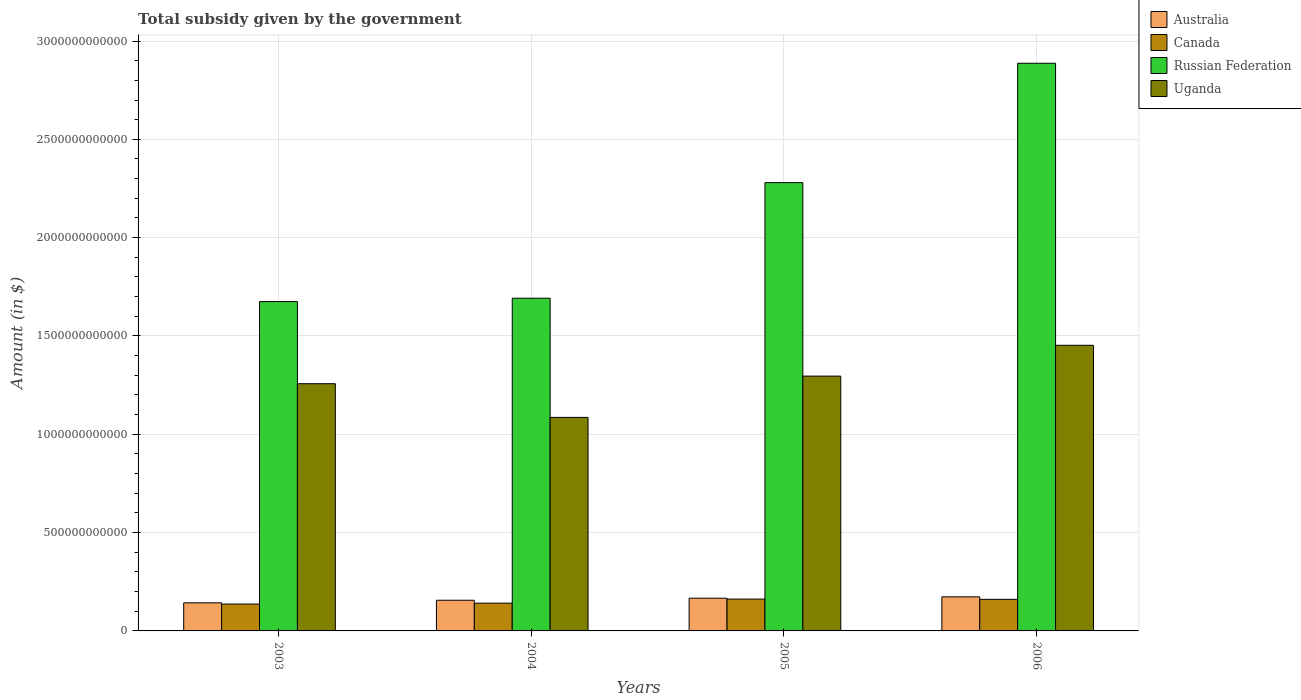How many different coloured bars are there?
Your answer should be very brief. 4. How many groups of bars are there?
Your answer should be very brief. 4. What is the total revenue collected by the government in Canada in 2004?
Your answer should be very brief. 1.41e+11. Across all years, what is the maximum total revenue collected by the government in Canada?
Make the answer very short. 1.62e+11. Across all years, what is the minimum total revenue collected by the government in Australia?
Provide a succinct answer. 1.43e+11. In which year was the total revenue collected by the government in Russian Federation maximum?
Provide a succinct answer. 2006. In which year was the total revenue collected by the government in Russian Federation minimum?
Give a very brief answer. 2003. What is the total total revenue collected by the government in Canada in the graph?
Make the answer very short. 6.00e+11. What is the difference between the total revenue collected by the government in Uganda in 2003 and that in 2004?
Give a very brief answer. 1.71e+11. What is the difference between the total revenue collected by the government in Russian Federation in 2005 and the total revenue collected by the government in Uganda in 2003?
Make the answer very short. 1.02e+12. What is the average total revenue collected by the government in Uganda per year?
Make the answer very short. 1.27e+12. In the year 2005, what is the difference between the total revenue collected by the government in Australia and total revenue collected by the government in Uganda?
Your answer should be very brief. -1.13e+12. What is the ratio of the total revenue collected by the government in Russian Federation in 2005 to that in 2006?
Your answer should be compact. 0.79. What is the difference between the highest and the second highest total revenue collected by the government in Canada?
Offer a very short reply. 1.41e+09. What is the difference between the highest and the lowest total revenue collected by the government in Canada?
Your answer should be compact. 2.53e+1. In how many years, is the total revenue collected by the government in Australia greater than the average total revenue collected by the government in Australia taken over all years?
Offer a terse response. 2. Is the sum of the total revenue collected by the government in Australia in 2005 and 2006 greater than the maximum total revenue collected by the government in Canada across all years?
Provide a short and direct response. Yes. What does the 4th bar from the right in 2004 represents?
Your answer should be compact. Australia. How many years are there in the graph?
Your answer should be compact. 4. What is the difference between two consecutive major ticks on the Y-axis?
Ensure brevity in your answer.  5.00e+11. Does the graph contain any zero values?
Offer a very short reply. No. Does the graph contain grids?
Offer a very short reply. Yes. Where does the legend appear in the graph?
Provide a succinct answer. Top right. How many legend labels are there?
Your answer should be compact. 4. What is the title of the graph?
Ensure brevity in your answer.  Total subsidy given by the government. Does "Fragile and conflict affected situations" appear as one of the legend labels in the graph?
Provide a succinct answer. No. What is the label or title of the X-axis?
Your response must be concise. Years. What is the label or title of the Y-axis?
Make the answer very short. Amount (in $). What is the Amount (in $) of Australia in 2003?
Provide a short and direct response. 1.43e+11. What is the Amount (in $) of Canada in 2003?
Make the answer very short. 1.37e+11. What is the Amount (in $) of Russian Federation in 2003?
Your answer should be very brief. 1.67e+12. What is the Amount (in $) of Uganda in 2003?
Keep it short and to the point. 1.26e+12. What is the Amount (in $) in Australia in 2004?
Your answer should be compact. 1.56e+11. What is the Amount (in $) in Canada in 2004?
Your answer should be compact. 1.41e+11. What is the Amount (in $) in Russian Federation in 2004?
Provide a succinct answer. 1.69e+12. What is the Amount (in $) of Uganda in 2004?
Your answer should be very brief. 1.09e+12. What is the Amount (in $) in Australia in 2005?
Offer a very short reply. 1.66e+11. What is the Amount (in $) of Canada in 2005?
Keep it short and to the point. 1.62e+11. What is the Amount (in $) of Russian Federation in 2005?
Provide a succinct answer. 2.28e+12. What is the Amount (in $) in Uganda in 2005?
Offer a terse response. 1.30e+12. What is the Amount (in $) in Australia in 2006?
Make the answer very short. 1.73e+11. What is the Amount (in $) in Canada in 2006?
Offer a very short reply. 1.61e+11. What is the Amount (in $) in Russian Federation in 2006?
Offer a very short reply. 2.89e+12. What is the Amount (in $) in Uganda in 2006?
Offer a very short reply. 1.45e+12. Across all years, what is the maximum Amount (in $) in Australia?
Make the answer very short. 1.73e+11. Across all years, what is the maximum Amount (in $) of Canada?
Your response must be concise. 1.62e+11. Across all years, what is the maximum Amount (in $) in Russian Federation?
Offer a very short reply. 2.89e+12. Across all years, what is the maximum Amount (in $) of Uganda?
Offer a very short reply. 1.45e+12. Across all years, what is the minimum Amount (in $) of Australia?
Provide a short and direct response. 1.43e+11. Across all years, what is the minimum Amount (in $) in Canada?
Your response must be concise. 1.37e+11. Across all years, what is the minimum Amount (in $) of Russian Federation?
Provide a succinct answer. 1.67e+12. Across all years, what is the minimum Amount (in $) in Uganda?
Provide a short and direct response. 1.09e+12. What is the total Amount (in $) in Australia in the graph?
Your answer should be compact. 6.39e+11. What is the total Amount (in $) in Canada in the graph?
Your answer should be very brief. 6.00e+11. What is the total Amount (in $) in Russian Federation in the graph?
Offer a terse response. 8.53e+12. What is the total Amount (in $) of Uganda in the graph?
Give a very brief answer. 5.09e+12. What is the difference between the Amount (in $) in Australia in 2003 and that in 2004?
Your response must be concise. -1.31e+1. What is the difference between the Amount (in $) in Canada in 2003 and that in 2004?
Keep it short and to the point. -4.56e+09. What is the difference between the Amount (in $) of Russian Federation in 2003 and that in 2004?
Ensure brevity in your answer.  -1.70e+1. What is the difference between the Amount (in $) in Uganda in 2003 and that in 2004?
Provide a short and direct response. 1.71e+11. What is the difference between the Amount (in $) of Australia in 2003 and that in 2005?
Your answer should be very brief. -2.36e+1. What is the difference between the Amount (in $) of Canada in 2003 and that in 2005?
Offer a terse response. -2.53e+1. What is the difference between the Amount (in $) in Russian Federation in 2003 and that in 2005?
Ensure brevity in your answer.  -6.05e+11. What is the difference between the Amount (in $) of Uganda in 2003 and that in 2005?
Your answer should be very brief. -3.86e+1. What is the difference between the Amount (in $) in Australia in 2003 and that in 2006?
Make the answer very short. -3.04e+1. What is the difference between the Amount (in $) in Canada in 2003 and that in 2006?
Offer a very short reply. -2.39e+1. What is the difference between the Amount (in $) of Russian Federation in 2003 and that in 2006?
Make the answer very short. -1.21e+12. What is the difference between the Amount (in $) in Uganda in 2003 and that in 2006?
Provide a succinct answer. -1.95e+11. What is the difference between the Amount (in $) of Australia in 2004 and that in 2005?
Make the answer very short. -1.05e+1. What is the difference between the Amount (in $) of Canada in 2004 and that in 2005?
Offer a terse response. -2.08e+1. What is the difference between the Amount (in $) of Russian Federation in 2004 and that in 2005?
Your answer should be very brief. -5.88e+11. What is the difference between the Amount (in $) of Uganda in 2004 and that in 2005?
Make the answer very short. -2.10e+11. What is the difference between the Amount (in $) in Australia in 2004 and that in 2006?
Give a very brief answer. -1.73e+1. What is the difference between the Amount (in $) of Canada in 2004 and that in 2006?
Keep it short and to the point. -1.94e+1. What is the difference between the Amount (in $) of Russian Federation in 2004 and that in 2006?
Provide a succinct answer. -1.19e+12. What is the difference between the Amount (in $) of Uganda in 2004 and that in 2006?
Your response must be concise. -3.67e+11. What is the difference between the Amount (in $) in Australia in 2005 and that in 2006?
Provide a succinct answer. -6.85e+09. What is the difference between the Amount (in $) in Canada in 2005 and that in 2006?
Your response must be concise. 1.41e+09. What is the difference between the Amount (in $) of Russian Federation in 2005 and that in 2006?
Ensure brevity in your answer.  -6.07e+11. What is the difference between the Amount (in $) of Uganda in 2005 and that in 2006?
Your answer should be compact. -1.57e+11. What is the difference between the Amount (in $) of Australia in 2003 and the Amount (in $) of Canada in 2004?
Your answer should be compact. 1.65e+09. What is the difference between the Amount (in $) in Australia in 2003 and the Amount (in $) in Russian Federation in 2004?
Provide a short and direct response. -1.55e+12. What is the difference between the Amount (in $) in Australia in 2003 and the Amount (in $) in Uganda in 2004?
Your answer should be very brief. -9.43e+11. What is the difference between the Amount (in $) of Canada in 2003 and the Amount (in $) of Russian Federation in 2004?
Provide a succinct answer. -1.56e+12. What is the difference between the Amount (in $) of Canada in 2003 and the Amount (in $) of Uganda in 2004?
Your answer should be compact. -9.49e+11. What is the difference between the Amount (in $) in Russian Federation in 2003 and the Amount (in $) in Uganda in 2004?
Your response must be concise. 5.89e+11. What is the difference between the Amount (in $) of Australia in 2003 and the Amount (in $) of Canada in 2005?
Your response must be concise. -1.91e+1. What is the difference between the Amount (in $) in Australia in 2003 and the Amount (in $) in Russian Federation in 2005?
Offer a terse response. -2.14e+12. What is the difference between the Amount (in $) of Australia in 2003 and the Amount (in $) of Uganda in 2005?
Your answer should be compact. -1.15e+12. What is the difference between the Amount (in $) of Canada in 2003 and the Amount (in $) of Russian Federation in 2005?
Offer a very short reply. -2.14e+12. What is the difference between the Amount (in $) in Canada in 2003 and the Amount (in $) in Uganda in 2005?
Provide a short and direct response. -1.16e+12. What is the difference between the Amount (in $) in Russian Federation in 2003 and the Amount (in $) in Uganda in 2005?
Offer a very short reply. 3.79e+11. What is the difference between the Amount (in $) in Australia in 2003 and the Amount (in $) in Canada in 2006?
Provide a succinct answer. -1.77e+1. What is the difference between the Amount (in $) of Australia in 2003 and the Amount (in $) of Russian Federation in 2006?
Your answer should be very brief. -2.74e+12. What is the difference between the Amount (in $) in Australia in 2003 and the Amount (in $) in Uganda in 2006?
Give a very brief answer. -1.31e+12. What is the difference between the Amount (in $) of Canada in 2003 and the Amount (in $) of Russian Federation in 2006?
Give a very brief answer. -2.75e+12. What is the difference between the Amount (in $) in Canada in 2003 and the Amount (in $) in Uganda in 2006?
Your answer should be very brief. -1.32e+12. What is the difference between the Amount (in $) of Russian Federation in 2003 and the Amount (in $) of Uganda in 2006?
Offer a very short reply. 2.22e+11. What is the difference between the Amount (in $) in Australia in 2004 and the Amount (in $) in Canada in 2005?
Your answer should be very brief. -6.00e+09. What is the difference between the Amount (in $) in Australia in 2004 and the Amount (in $) in Russian Federation in 2005?
Keep it short and to the point. -2.12e+12. What is the difference between the Amount (in $) of Australia in 2004 and the Amount (in $) of Uganda in 2005?
Provide a short and direct response. -1.14e+12. What is the difference between the Amount (in $) in Canada in 2004 and the Amount (in $) in Russian Federation in 2005?
Your answer should be compact. -2.14e+12. What is the difference between the Amount (in $) in Canada in 2004 and the Amount (in $) in Uganda in 2005?
Provide a succinct answer. -1.15e+12. What is the difference between the Amount (in $) in Russian Federation in 2004 and the Amount (in $) in Uganda in 2005?
Offer a terse response. 3.96e+11. What is the difference between the Amount (in $) in Australia in 2004 and the Amount (in $) in Canada in 2006?
Provide a succinct answer. -4.59e+09. What is the difference between the Amount (in $) of Australia in 2004 and the Amount (in $) of Russian Federation in 2006?
Your response must be concise. -2.73e+12. What is the difference between the Amount (in $) in Australia in 2004 and the Amount (in $) in Uganda in 2006?
Your response must be concise. -1.30e+12. What is the difference between the Amount (in $) of Canada in 2004 and the Amount (in $) of Russian Federation in 2006?
Give a very brief answer. -2.75e+12. What is the difference between the Amount (in $) of Canada in 2004 and the Amount (in $) of Uganda in 2006?
Offer a terse response. -1.31e+12. What is the difference between the Amount (in $) of Russian Federation in 2004 and the Amount (in $) of Uganda in 2006?
Ensure brevity in your answer.  2.39e+11. What is the difference between the Amount (in $) of Australia in 2005 and the Amount (in $) of Canada in 2006?
Offer a terse response. 5.89e+09. What is the difference between the Amount (in $) in Australia in 2005 and the Amount (in $) in Russian Federation in 2006?
Your response must be concise. -2.72e+12. What is the difference between the Amount (in $) of Australia in 2005 and the Amount (in $) of Uganda in 2006?
Your response must be concise. -1.29e+12. What is the difference between the Amount (in $) in Canada in 2005 and the Amount (in $) in Russian Federation in 2006?
Your response must be concise. -2.72e+12. What is the difference between the Amount (in $) of Canada in 2005 and the Amount (in $) of Uganda in 2006?
Ensure brevity in your answer.  -1.29e+12. What is the difference between the Amount (in $) in Russian Federation in 2005 and the Amount (in $) in Uganda in 2006?
Offer a very short reply. 8.27e+11. What is the average Amount (in $) in Australia per year?
Give a very brief answer. 1.60e+11. What is the average Amount (in $) in Canada per year?
Your answer should be very brief. 1.50e+11. What is the average Amount (in $) in Russian Federation per year?
Offer a terse response. 2.13e+12. What is the average Amount (in $) in Uganda per year?
Ensure brevity in your answer.  1.27e+12. In the year 2003, what is the difference between the Amount (in $) in Australia and Amount (in $) in Canada?
Make the answer very short. 6.21e+09. In the year 2003, what is the difference between the Amount (in $) in Australia and Amount (in $) in Russian Federation?
Ensure brevity in your answer.  -1.53e+12. In the year 2003, what is the difference between the Amount (in $) in Australia and Amount (in $) in Uganda?
Offer a very short reply. -1.11e+12. In the year 2003, what is the difference between the Amount (in $) of Canada and Amount (in $) of Russian Federation?
Ensure brevity in your answer.  -1.54e+12. In the year 2003, what is the difference between the Amount (in $) of Canada and Amount (in $) of Uganda?
Your answer should be very brief. -1.12e+12. In the year 2003, what is the difference between the Amount (in $) of Russian Federation and Amount (in $) of Uganda?
Your response must be concise. 4.18e+11. In the year 2004, what is the difference between the Amount (in $) in Australia and Amount (in $) in Canada?
Keep it short and to the point. 1.48e+1. In the year 2004, what is the difference between the Amount (in $) in Australia and Amount (in $) in Russian Federation?
Provide a short and direct response. -1.54e+12. In the year 2004, what is the difference between the Amount (in $) in Australia and Amount (in $) in Uganda?
Offer a terse response. -9.30e+11. In the year 2004, what is the difference between the Amount (in $) in Canada and Amount (in $) in Russian Federation?
Your answer should be very brief. -1.55e+12. In the year 2004, what is the difference between the Amount (in $) of Canada and Amount (in $) of Uganda?
Provide a succinct answer. -9.45e+11. In the year 2004, what is the difference between the Amount (in $) in Russian Federation and Amount (in $) in Uganda?
Provide a succinct answer. 6.06e+11. In the year 2005, what is the difference between the Amount (in $) of Australia and Amount (in $) of Canada?
Give a very brief answer. 4.48e+09. In the year 2005, what is the difference between the Amount (in $) of Australia and Amount (in $) of Russian Federation?
Your response must be concise. -2.11e+12. In the year 2005, what is the difference between the Amount (in $) of Australia and Amount (in $) of Uganda?
Offer a terse response. -1.13e+12. In the year 2005, what is the difference between the Amount (in $) in Canada and Amount (in $) in Russian Federation?
Ensure brevity in your answer.  -2.12e+12. In the year 2005, what is the difference between the Amount (in $) in Canada and Amount (in $) in Uganda?
Ensure brevity in your answer.  -1.13e+12. In the year 2005, what is the difference between the Amount (in $) of Russian Federation and Amount (in $) of Uganda?
Provide a succinct answer. 9.84e+11. In the year 2006, what is the difference between the Amount (in $) in Australia and Amount (in $) in Canada?
Your response must be concise. 1.27e+1. In the year 2006, what is the difference between the Amount (in $) in Australia and Amount (in $) in Russian Federation?
Give a very brief answer. -2.71e+12. In the year 2006, what is the difference between the Amount (in $) of Australia and Amount (in $) of Uganda?
Your answer should be compact. -1.28e+12. In the year 2006, what is the difference between the Amount (in $) of Canada and Amount (in $) of Russian Federation?
Your answer should be compact. -2.73e+12. In the year 2006, what is the difference between the Amount (in $) in Canada and Amount (in $) in Uganda?
Provide a short and direct response. -1.29e+12. In the year 2006, what is the difference between the Amount (in $) of Russian Federation and Amount (in $) of Uganda?
Offer a very short reply. 1.43e+12. What is the ratio of the Amount (in $) in Australia in 2003 to that in 2004?
Ensure brevity in your answer.  0.92. What is the ratio of the Amount (in $) in Canada in 2003 to that in 2004?
Provide a succinct answer. 0.97. What is the ratio of the Amount (in $) of Uganda in 2003 to that in 2004?
Give a very brief answer. 1.16. What is the ratio of the Amount (in $) of Australia in 2003 to that in 2005?
Your answer should be compact. 0.86. What is the ratio of the Amount (in $) in Canada in 2003 to that in 2005?
Keep it short and to the point. 0.84. What is the ratio of the Amount (in $) of Russian Federation in 2003 to that in 2005?
Keep it short and to the point. 0.73. What is the ratio of the Amount (in $) of Uganda in 2003 to that in 2005?
Ensure brevity in your answer.  0.97. What is the ratio of the Amount (in $) of Australia in 2003 to that in 2006?
Provide a short and direct response. 0.82. What is the ratio of the Amount (in $) in Canada in 2003 to that in 2006?
Provide a short and direct response. 0.85. What is the ratio of the Amount (in $) in Russian Federation in 2003 to that in 2006?
Provide a succinct answer. 0.58. What is the ratio of the Amount (in $) of Uganda in 2003 to that in 2006?
Give a very brief answer. 0.87. What is the ratio of the Amount (in $) in Australia in 2004 to that in 2005?
Offer a very short reply. 0.94. What is the ratio of the Amount (in $) of Canada in 2004 to that in 2005?
Keep it short and to the point. 0.87. What is the ratio of the Amount (in $) of Russian Federation in 2004 to that in 2005?
Make the answer very short. 0.74. What is the ratio of the Amount (in $) in Uganda in 2004 to that in 2005?
Provide a succinct answer. 0.84. What is the ratio of the Amount (in $) of Australia in 2004 to that in 2006?
Provide a short and direct response. 0.9. What is the ratio of the Amount (in $) in Canada in 2004 to that in 2006?
Your answer should be very brief. 0.88. What is the ratio of the Amount (in $) of Russian Federation in 2004 to that in 2006?
Keep it short and to the point. 0.59. What is the ratio of the Amount (in $) of Uganda in 2004 to that in 2006?
Make the answer very short. 0.75. What is the ratio of the Amount (in $) of Australia in 2005 to that in 2006?
Provide a short and direct response. 0.96. What is the ratio of the Amount (in $) in Canada in 2005 to that in 2006?
Keep it short and to the point. 1.01. What is the ratio of the Amount (in $) in Russian Federation in 2005 to that in 2006?
Make the answer very short. 0.79. What is the ratio of the Amount (in $) of Uganda in 2005 to that in 2006?
Your answer should be very brief. 0.89. What is the difference between the highest and the second highest Amount (in $) of Australia?
Your response must be concise. 6.85e+09. What is the difference between the highest and the second highest Amount (in $) of Canada?
Make the answer very short. 1.41e+09. What is the difference between the highest and the second highest Amount (in $) of Russian Federation?
Keep it short and to the point. 6.07e+11. What is the difference between the highest and the second highest Amount (in $) of Uganda?
Offer a terse response. 1.57e+11. What is the difference between the highest and the lowest Amount (in $) of Australia?
Provide a succinct answer. 3.04e+1. What is the difference between the highest and the lowest Amount (in $) of Canada?
Provide a succinct answer. 2.53e+1. What is the difference between the highest and the lowest Amount (in $) of Russian Federation?
Make the answer very short. 1.21e+12. What is the difference between the highest and the lowest Amount (in $) of Uganda?
Offer a very short reply. 3.67e+11. 